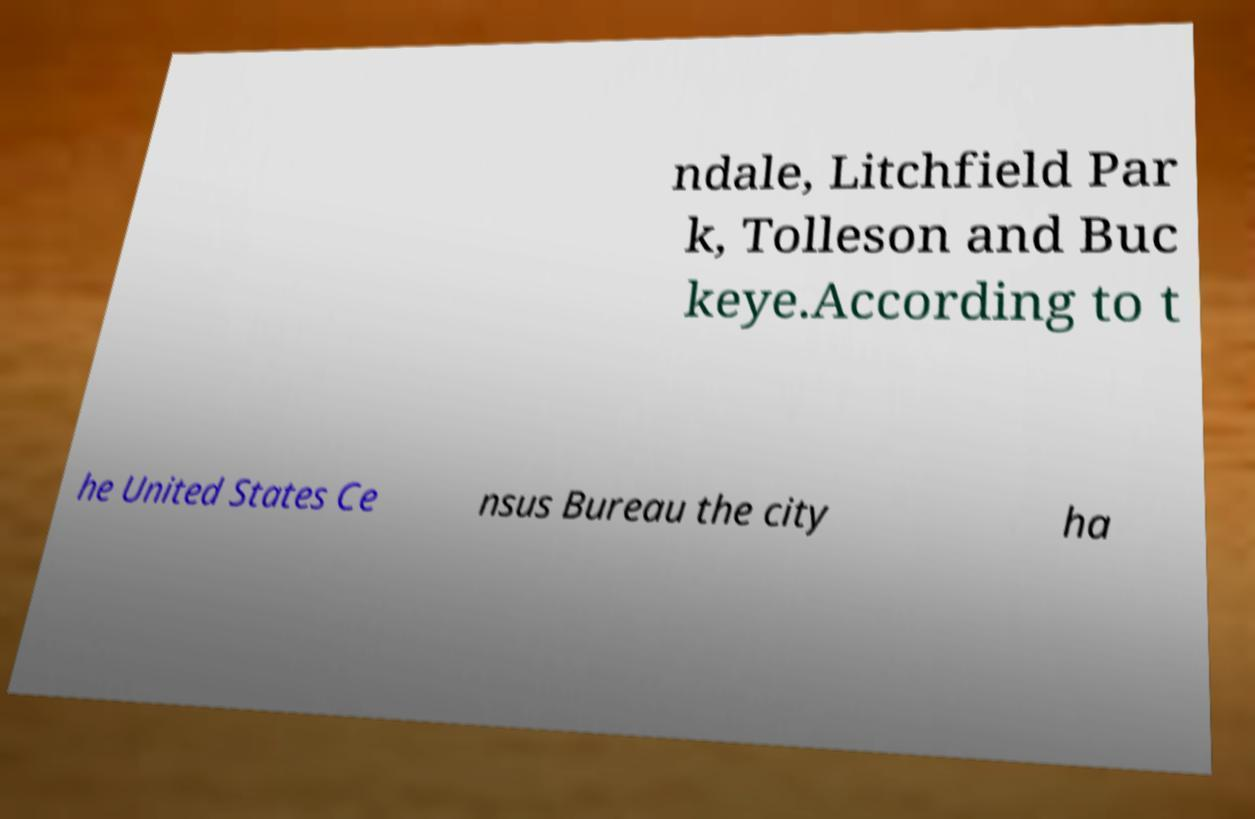Please identify and transcribe the text found in this image. ndale, Litchfield Par k, Tolleson and Buc keye.According to t he United States Ce nsus Bureau the city ha 